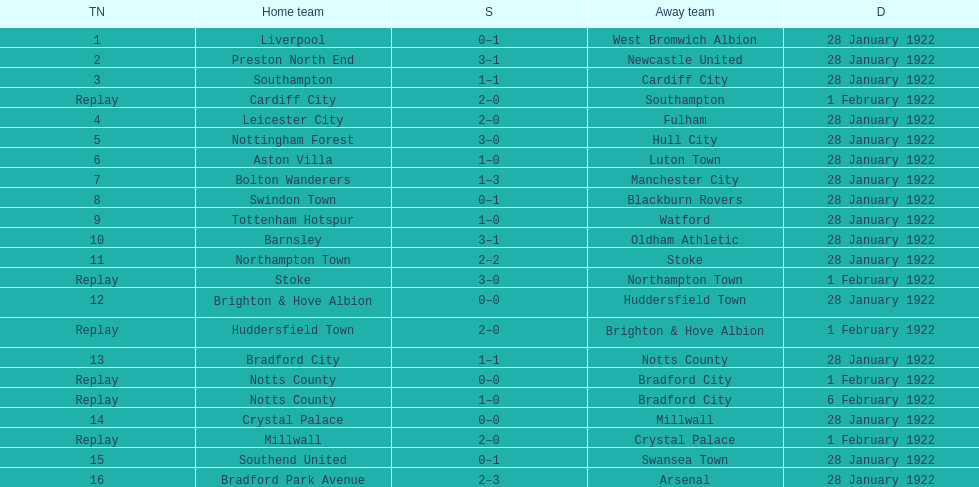How many games had no points scored? 3. 